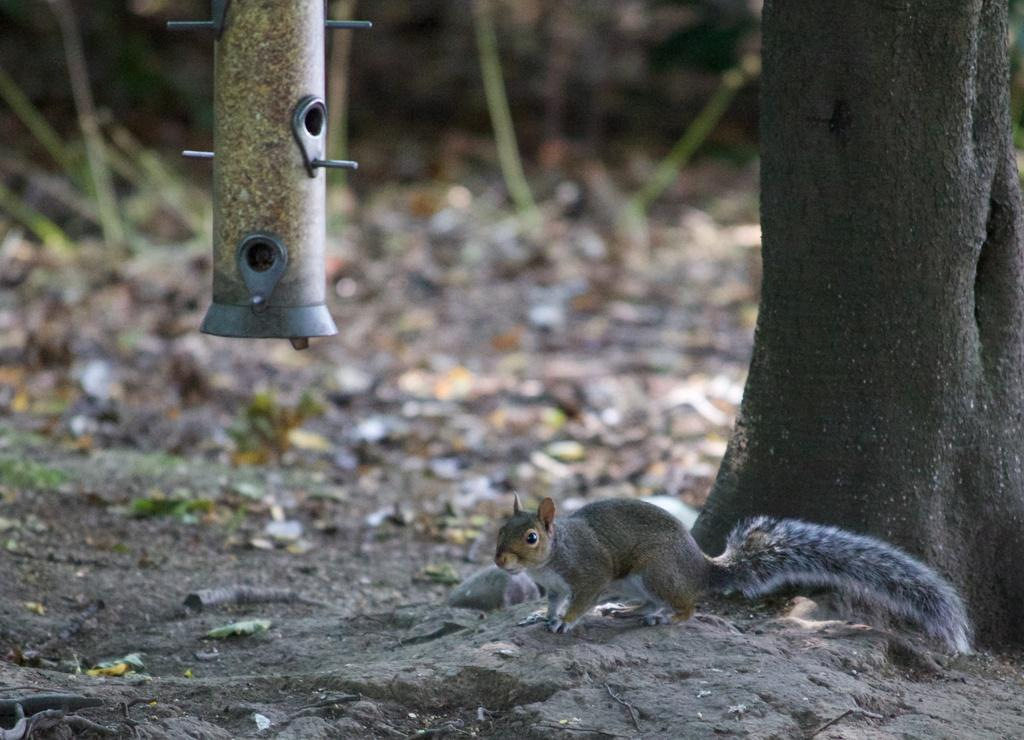What type of animal can be seen in the picture? There is a squirrel in the picture. What natural element is present in the picture? There is a tree in the picture. What is covering the ground in the picture? Dry leaves and soil are visible on the floor. What type of flowers can be seen growing near the sea in the image? There is no sea or flowers present in the image; it features a squirrel, a tree, dry leaves, and soil. 